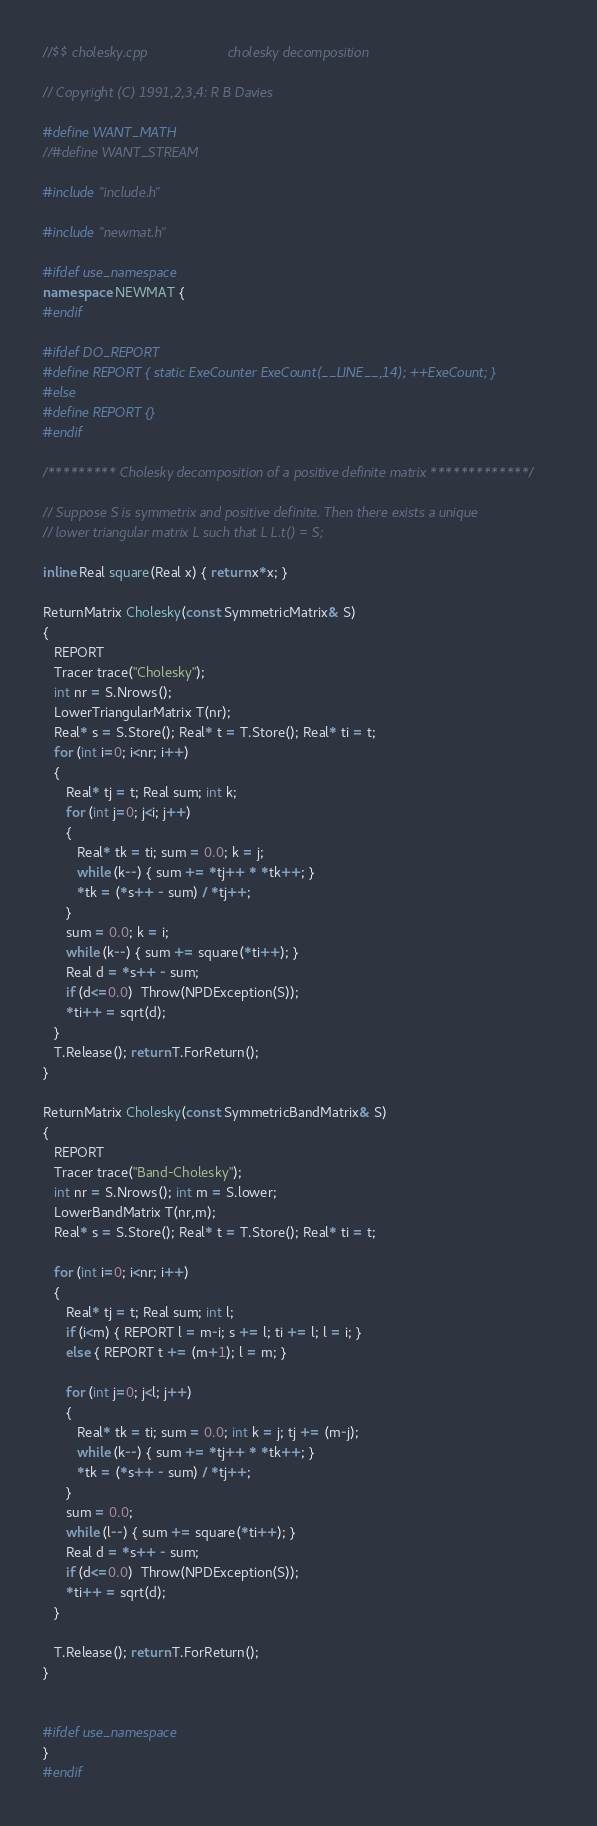Convert code to text. <code><loc_0><loc_0><loc_500><loc_500><_C++_>//$$ cholesky.cpp                     cholesky decomposition

// Copyright (C) 1991,2,3,4: R B Davies

#define WANT_MATH
//#define WANT_STREAM

#include "include.h"

#include "newmat.h"

#ifdef use_namespace
namespace NEWMAT {
#endif

#ifdef DO_REPORT
#define REPORT { static ExeCounter ExeCount(__LINE__,14); ++ExeCount; }
#else
#define REPORT {}
#endif

/********* Cholesky decomposition of a positive definite matrix *************/

// Suppose S is symmetrix and positive definite. Then there exists a unique
// lower triangular matrix L such that L L.t() = S;

inline Real square(Real x) { return x*x; }

ReturnMatrix Cholesky(const SymmetricMatrix& S)
{
   REPORT
   Tracer trace("Cholesky");
   int nr = S.Nrows();
   LowerTriangularMatrix T(nr);
   Real* s = S.Store(); Real* t = T.Store(); Real* ti = t;
   for (int i=0; i<nr; i++)
   {
      Real* tj = t; Real sum; int k;
      for (int j=0; j<i; j++)
      {
         Real* tk = ti; sum = 0.0; k = j;
         while (k--) { sum += *tj++ * *tk++; }
         *tk = (*s++ - sum) / *tj++;
      }
      sum = 0.0; k = i;
      while (k--) { sum += square(*ti++); }
      Real d = *s++ - sum;
      if (d<=0.0)  Throw(NPDException(S));
      *ti++ = sqrt(d);
   }
   T.Release(); return T.ForReturn();
}

ReturnMatrix Cholesky(const SymmetricBandMatrix& S)
{
   REPORT
   Tracer trace("Band-Cholesky");
   int nr = S.Nrows(); int m = S.lower;
   LowerBandMatrix T(nr,m);
   Real* s = S.Store(); Real* t = T.Store(); Real* ti = t;

   for (int i=0; i<nr; i++)
   {
      Real* tj = t; Real sum; int l;
      if (i<m) { REPORT l = m-i; s += l; ti += l; l = i; }
      else { REPORT t += (m+1); l = m; }

      for (int j=0; j<l; j++)
      {
         Real* tk = ti; sum = 0.0; int k = j; tj += (m-j);
         while (k--) { sum += *tj++ * *tk++; }
         *tk = (*s++ - sum) / *tj++;
      }
      sum = 0.0;
      while (l--) { sum += square(*ti++); }
      Real d = *s++ - sum;
      if (d<=0.0)  Throw(NPDException(S));
      *ti++ = sqrt(d);
   }

   T.Release(); return T.ForReturn();
}


#ifdef use_namespace
}
#endif

</code> 